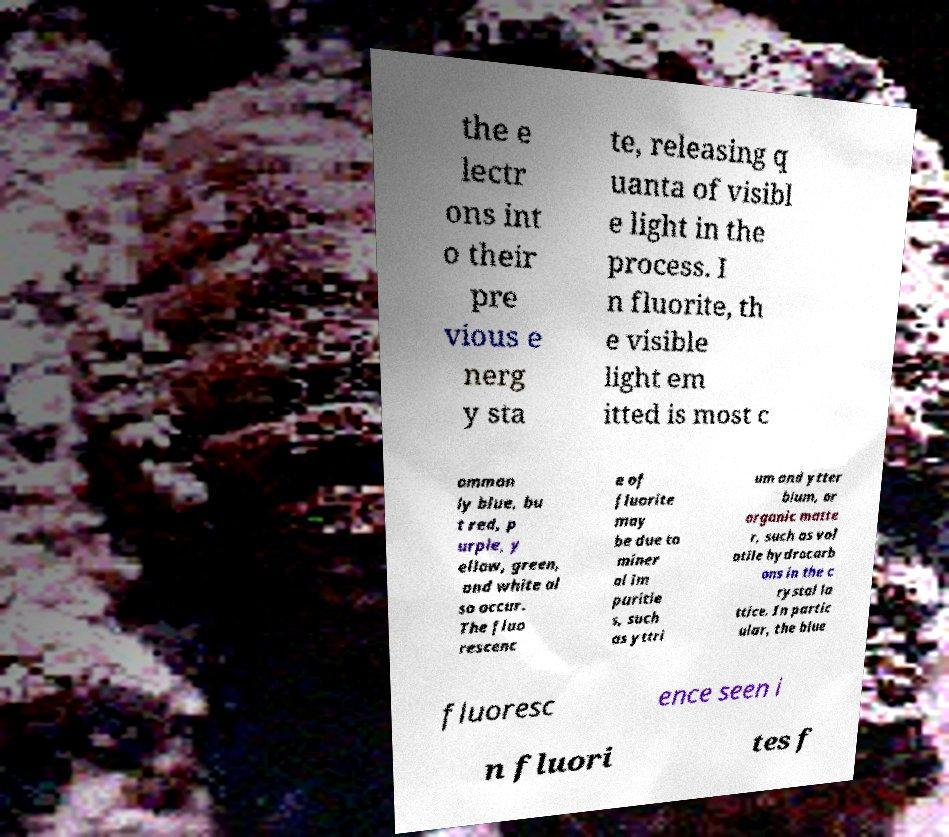There's text embedded in this image that I need extracted. Can you transcribe it verbatim? the e lectr ons int o their pre vious e nerg y sta te, releasing q uanta of visibl e light in the process. I n fluorite, th e visible light em itted is most c ommon ly blue, bu t red, p urple, y ellow, green, and white al so occur. The fluo rescenc e of fluorite may be due to miner al im puritie s, such as yttri um and ytter bium, or organic matte r, such as vol atile hydrocarb ons in the c rystal la ttice. In partic ular, the blue fluoresc ence seen i n fluori tes f 